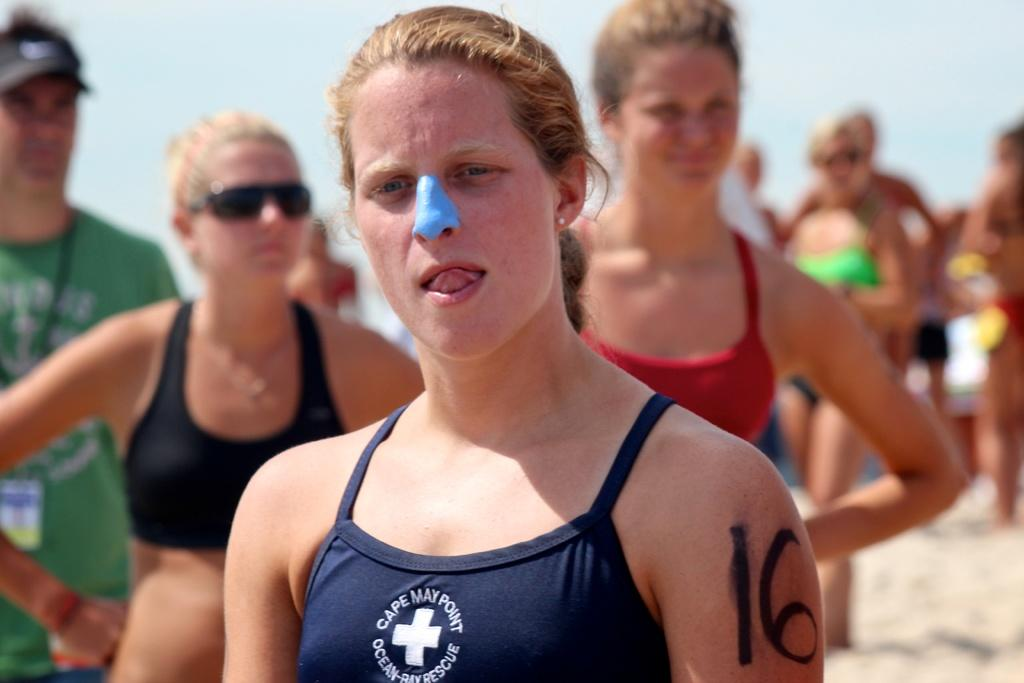<image>
Present a compact description of the photo's key features. woman on beach with blue powder on nose, 16 written on arm and her suit has cape may point ocean-bay rescue on it 